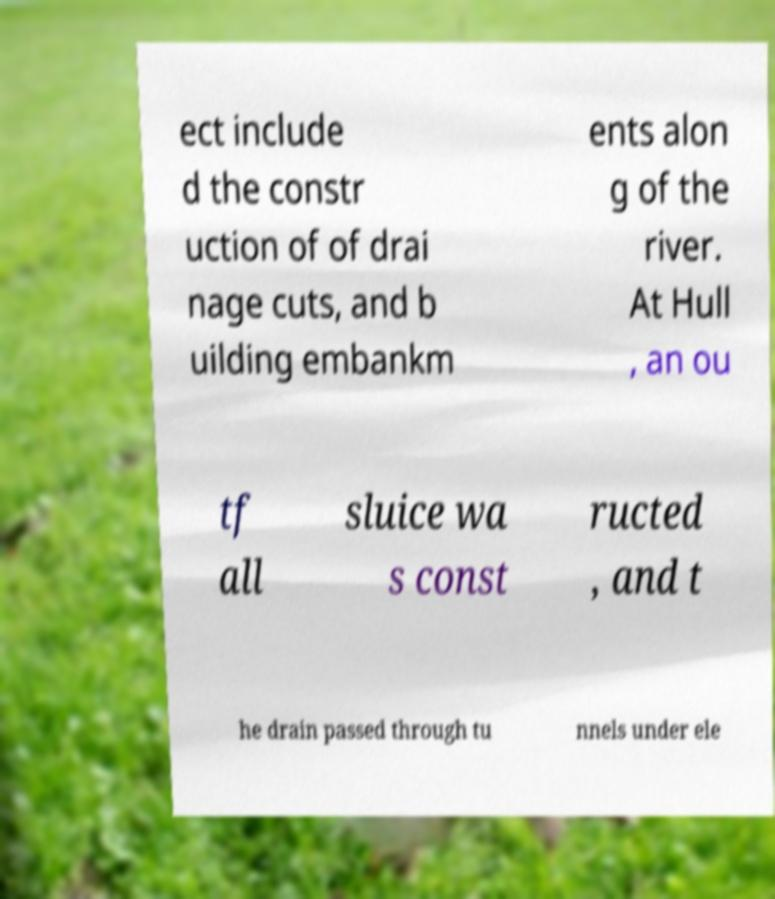Please read and relay the text visible in this image. What does it say? ect include d the constr uction of of drai nage cuts, and b uilding embankm ents alon g of the river. At Hull , an ou tf all sluice wa s const ructed , and t he drain passed through tu nnels under ele 